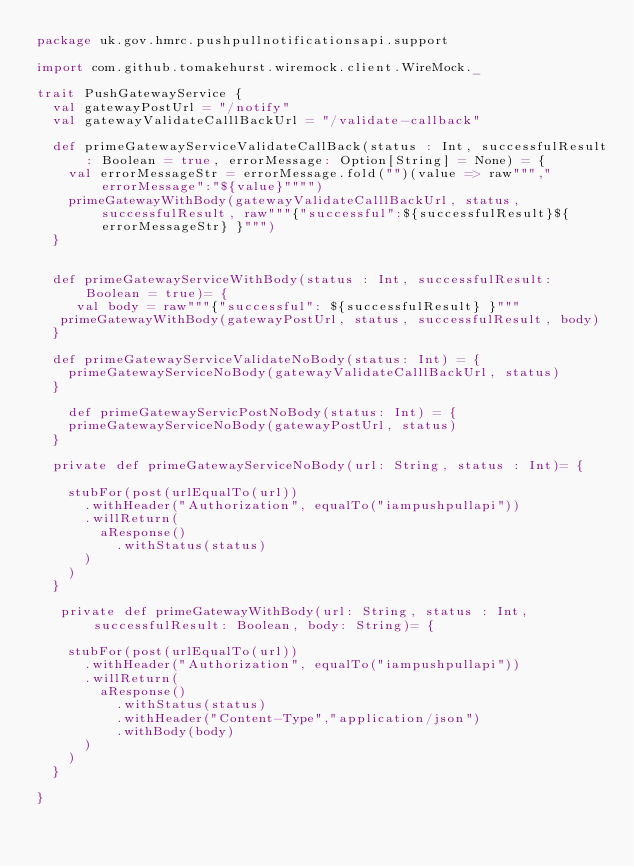Convert code to text. <code><loc_0><loc_0><loc_500><loc_500><_Scala_>package uk.gov.hmrc.pushpullnotificationsapi.support

import com.github.tomakehurst.wiremock.client.WireMock._

trait PushGatewayService {
  val gatewayPostUrl = "/notify"
  val gatewayValidateCalllBackUrl = "/validate-callback"

  def primeGatewayServiceValidateCallBack(status : Int, successfulResult: Boolean = true, errorMessage: Option[String] = None) = {
    val errorMessageStr = errorMessage.fold("")(value => raw""","errorMessage":"${value}"""")
    primeGatewayWithBody(gatewayValidateCalllBackUrl, status, successfulResult, raw"""{"successful":${successfulResult}${errorMessageStr} }""")
  }


  def primeGatewayServiceWithBody(status : Int, successfulResult: Boolean = true)= {
     val body = raw"""{"successful": ${successfulResult} }"""
   primeGatewayWithBody(gatewayPostUrl, status, successfulResult, body)
  }

  def primeGatewayServiceValidateNoBody(status: Int) = {
    primeGatewayServiceNoBody(gatewayValidateCalllBackUrl, status)
  }

    def primeGatewayServicPostNoBody(status: Int) = {
    primeGatewayServiceNoBody(gatewayPostUrl, status)
  }

  private def primeGatewayServiceNoBody(url: String, status : Int)= {

    stubFor(post(urlEqualTo(url))
      .withHeader("Authorization", equalTo("iampushpullapi"))
      .willReturn(
        aResponse()
          .withStatus(status)
      )
    )
  }

   private def primeGatewayWithBody(url: String, status : Int, successfulResult: Boolean, body: String)= {
   
    stubFor(post(urlEqualTo(url))
      .withHeader("Authorization", equalTo("iampushpullapi"))
      .willReturn(
        aResponse()
          .withStatus(status)
          .withHeader("Content-Type","application/json")
          .withBody(body)
      )
    )
  }

}
</code> 